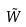<formula> <loc_0><loc_0><loc_500><loc_500>\tilde { W }</formula> 